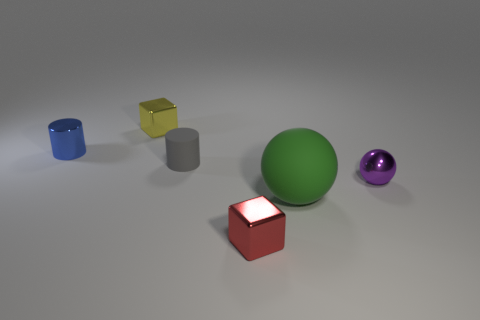Add 1 purple rubber objects. How many objects exist? 7 Subtract all blocks. How many objects are left? 4 Subtract 0 yellow cylinders. How many objects are left? 6 Subtract all tiny gray rubber objects. Subtract all small yellow metal objects. How many objects are left? 4 Add 1 small blocks. How many small blocks are left? 3 Add 4 tiny yellow rubber cylinders. How many tiny yellow rubber cylinders exist? 4 